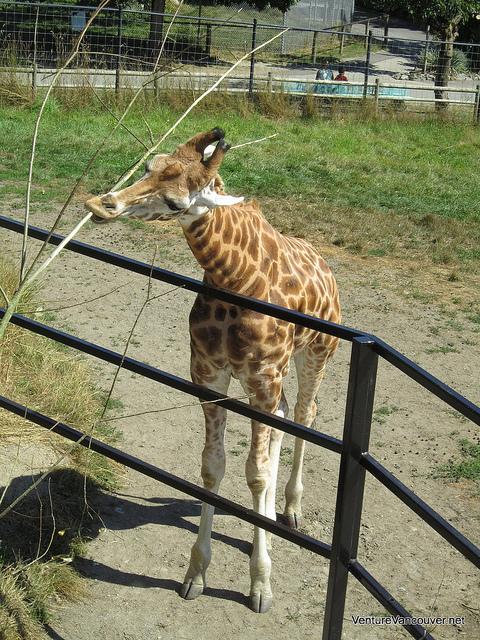What color is the fence?
Be succinct. Black. Is the giraffe full grown?
Quick response, please. No. Is the giraffe bored?
Answer briefly. No. 